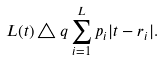Convert formula to latex. <formula><loc_0><loc_0><loc_500><loc_500>L ( t ) \triangle q \sum _ { i = 1 } ^ { L } p _ { i } | t - r _ { i } | .</formula> 